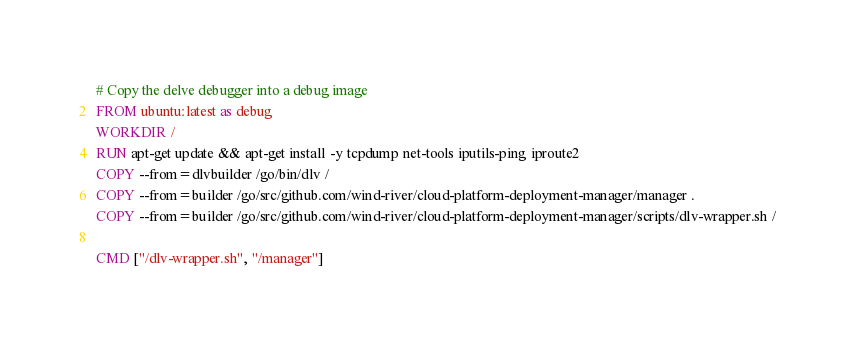Convert code to text. <code><loc_0><loc_0><loc_500><loc_500><_Dockerfile_># Copy the delve debugger into a debug image
FROM ubuntu:latest as debug
WORKDIR /
RUN apt-get update && apt-get install -y tcpdump net-tools iputils-ping iproute2
COPY --from=dlvbuilder /go/bin/dlv /
COPY --from=builder /go/src/github.com/wind-river/cloud-platform-deployment-manager/manager .
COPY --from=builder /go/src/github.com/wind-river/cloud-platform-deployment-manager/scripts/dlv-wrapper.sh /

CMD ["/dlv-wrapper.sh", "/manager"]
</code> 